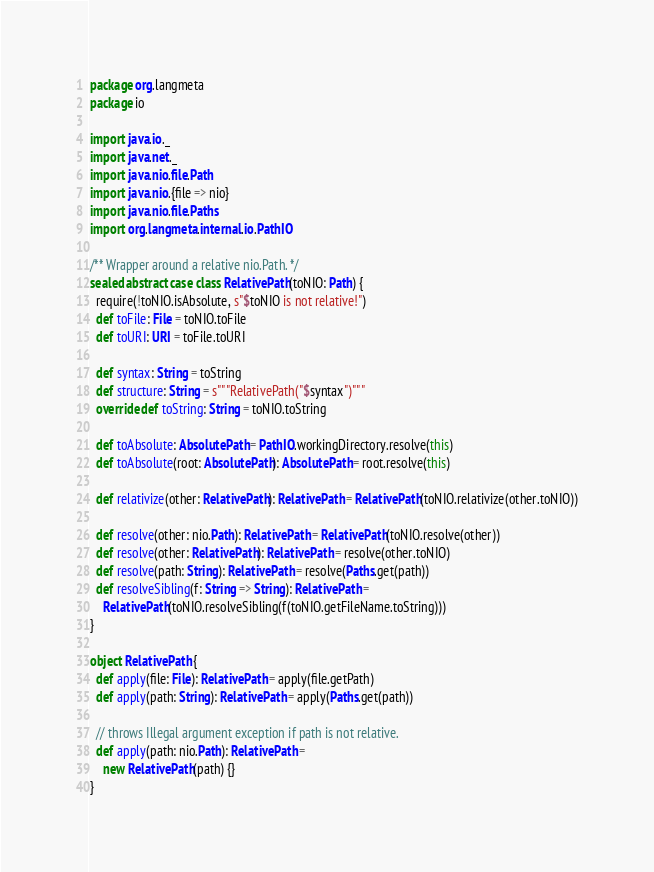Convert code to text. <code><loc_0><loc_0><loc_500><loc_500><_Scala_>package org.langmeta
package io

import java.io._
import java.net._
import java.nio.file.Path
import java.nio.{file => nio}
import java.nio.file.Paths
import org.langmeta.internal.io.PathIO

/** Wrapper around a relative nio.Path. */
sealed abstract case class RelativePath(toNIO: Path) {
  require(!toNIO.isAbsolute, s"$toNIO is not relative!")
  def toFile: File = toNIO.toFile
  def toURI: URI = toFile.toURI

  def syntax: String = toString
  def structure: String = s"""RelativePath("$syntax")"""
  override def toString: String = toNIO.toString

  def toAbsolute: AbsolutePath = PathIO.workingDirectory.resolve(this)
  def toAbsolute(root: AbsolutePath): AbsolutePath = root.resolve(this)

  def relativize(other: RelativePath): RelativePath = RelativePath(toNIO.relativize(other.toNIO))

  def resolve(other: nio.Path): RelativePath = RelativePath(toNIO.resolve(other))
  def resolve(other: RelativePath): RelativePath = resolve(other.toNIO)
  def resolve(path: String): RelativePath = resolve(Paths.get(path))
  def resolveSibling(f: String => String): RelativePath =
    RelativePath(toNIO.resolveSibling(f(toNIO.getFileName.toString)))
}

object RelativePath {
  def apply(file: File): RelativePath = apply(file.getPath)
  def apply(path: String): RelativePath = apply(Paths.get(path))

  // throws Illegal argument exception if path is not relative.
  def apply(path: nio.Path): RelativePath =
    new RelativePath(path) {}
}
</code> 